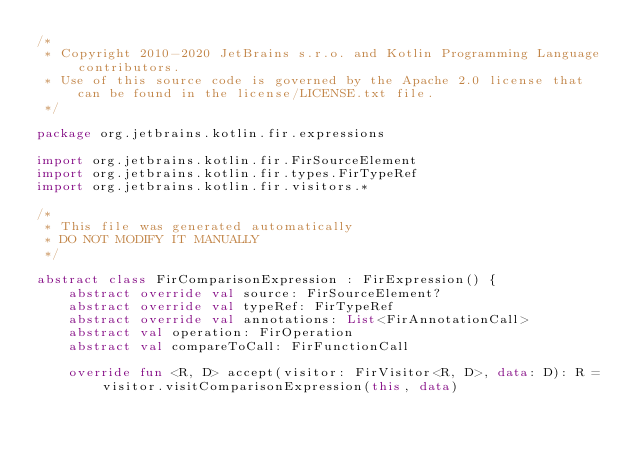Convert code to text. <code><loc_0><loc_0><loc_500><loc_500><_Kotlin_>/*
 * Copyright 2010-2020 JetBrains s.r.o. and Kotlin Programming Language contributors.
 * Use of this source code is governed by the Apache 2.0 license that can be found in the license/LICENSE.txt file.
 */

package org.jetbrains.kotlin.fir.expressions

import org.jetbrains.kotlin.fir.FirSourceElement
import org.jetbrains.kotlin.fir.types.FirTypeRef
import org.jetbrains.kotlin.fir.visitors.*

/*
 * This file was generated automatically
 * DO NOT MODIFY IT MANUALLY
 */

abstract class FirComparisonExpression : FirExpression() {
    abstract override val source: FirSourceElement?
    abstract override val typeRef: FirTypeRef
    abstract override val annotations: List<FirAnnotationCall>
    abstract val operation: FirOperation
    abstract val compareToCall: FirFunctionCall

    override fun <R, D> accept(visitor: FirVisitor<R, D>, data: D): R = visitor.visitComparisonExpression(this, data)
</code> 